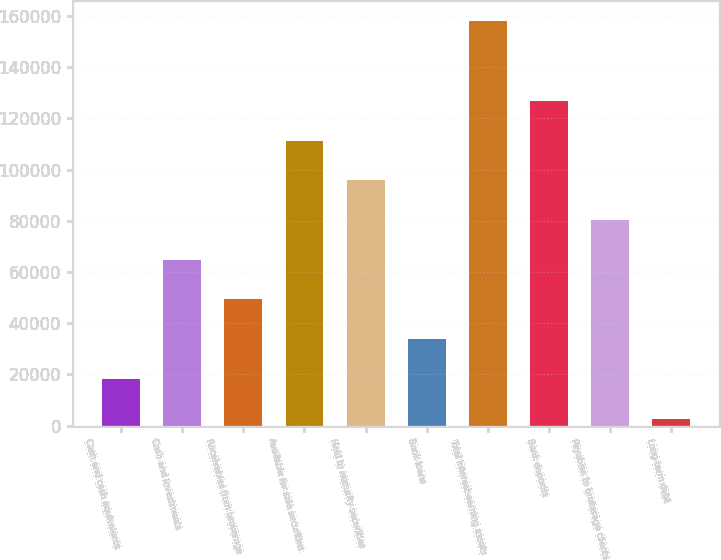<chart> <loc_0><loc_0><loc_500><loc_500><bar_chart><fcel>Cash and cash equivalents<fcel>Cash and investments<fcel>Receivables from brokerage<fcel>Available for sale securities<fcel>Held to maturity securities<fcel>Bank loans<fcel>Total interest-earning assets<fcel>Bank deposits<fcel>Payables to brokerage clients<fcel>Long-term debt<nl><fcel>18240.5<fcel>64811<fcel>49287.5<fcel>111382<fcel>95858<fcel>33764<fcel>157952<fcel>126905<fcel>80334.5<fcel>2717<nl></chart> 